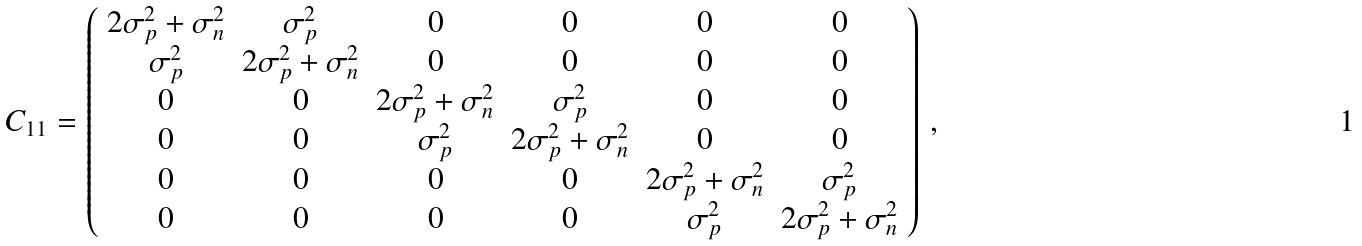Convert formula to latex. <formula><loc_0><loc_0><loc_500><loc_500>C _ { 1 1 } = \left ( \begin{array} { c c c c c c } 2 \sigma _ { p } ^ { 2 } + \sigma _ { n } ^ { 2 } & \sigma _ { p } ^ { 2 } & 0 & 0 & 0 & 0 \\ \sigma _ { p } ^ { 2 } & 2 \sigma _ { p } ^ { 2 } + \sigma _ { n } ^ { 2 } & 0 & 0 & 0 & 0 \\ 0 & 0 & 2 \sigma _ { p } ^ { 2 } + \sigma _ { n } ^ { 2 } & \sigma _ { p } ^ { 2 } & 0 & 0 \\ 0 & 0 & \sigma _ { p } ^ { 2 } & 2 \sigma _ { p } ^ { 2 } + \sigma _ { n } ^ { 2 } & 0 & 0 \\ 0 & 0 & 0 & 0 & 2 \sigma _ { p } ^ { 2 } + \sigma _ { n } ^ { 2 } & \sigma _ { p } ^ { 2 } \\ 0 & 0 & 0 & 0 & \sigma _ { p } ^ { 2 } & 2 \sigma _ { p } ^ { 2 } + \sigma _ { n } ^ { 2 } \\ \end{array} \right ) \, ,</formula> 